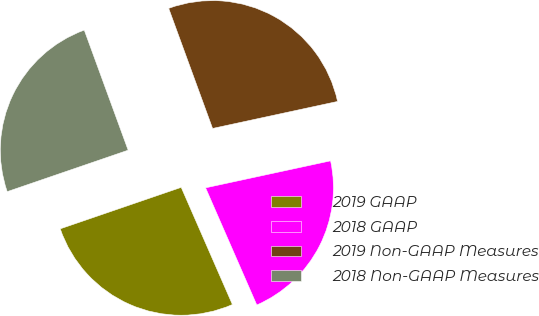Convert chart to OTSL. <chart><loc_0><loc_0><loc_500><loc_500><pie_chart><fcel>2019 GAAP<fcel>2018 GAAP<fcel>2019 Non-GAAP Measures<fcel>2018 Non-GAAP Measures<nl><fcel>26.3%<fcel>21.83%<fcel>27.19%<fcel>24.68%<nl></chart> 